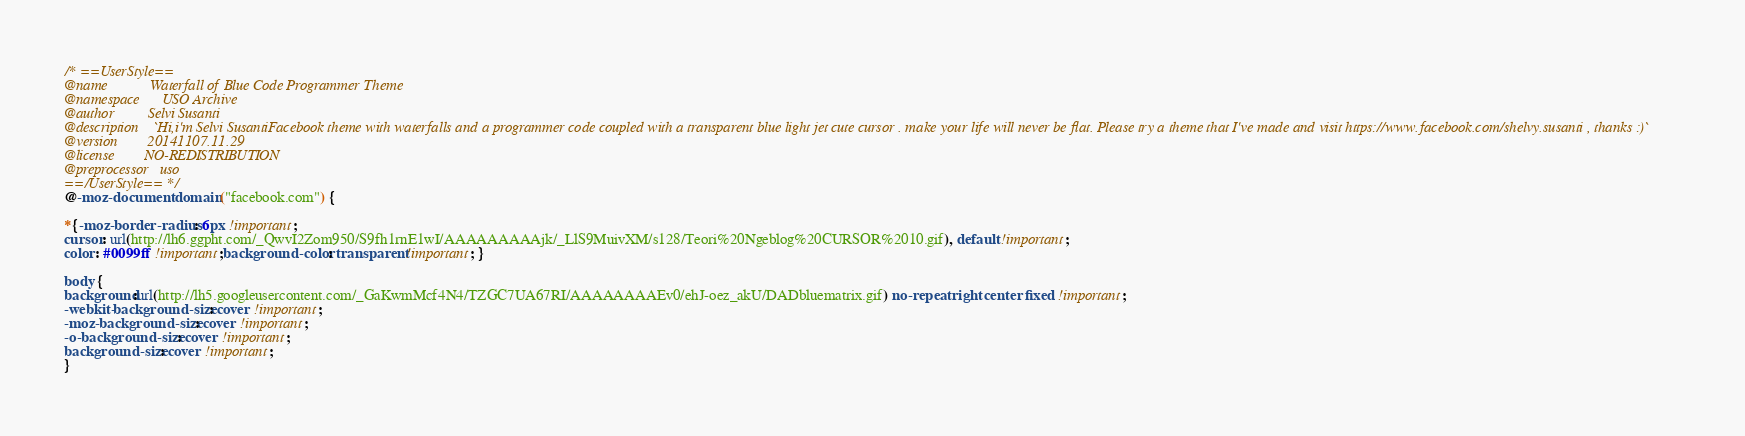Convert code to text. <code><loc_0><loc_0><loc_500><loc_500><_CSS_>/* ==UserStyle==
@name           Waterfall of Blue Code Programmer Theme
@namespace      USO Archive
@author         Selvi Susanti
@description    `Hi,i'm Selvi SusantiFacebook theme with waterfalls and a programmer code coupled with a transparent blue light jet cute cursor . make your life will never be flat. Please try a theme that I've made and visit https://www.facebook.com/shelvy.susanti , thanks :)`
@version        20141107.11.29
@license        NO-REDISTRIBUTION
@preprocessor   uso
==/UserStyle== */
@-moz-document domain("facebook.com") {

*{-moz-border-radius: 6px !important;
cursor: url(http://lh6.ggpht.com/_QwvI2Zom950/S9fh1rnE1wI/AAAAAAAAAjk/_LlS9MuivXM/s128/Teori%20Ngeblog%20CURSOR%2010.gif), default !important;
color: #0099ff !important;background-color: transparent !important; }

body {
background:url(http://lh5.googleusercontent.com/_GaKwmMcf4N4/TZGC7UA67RI/AAAAAAAAEv0/ehJ-oez_akU/DADbluematrix.gif) no-repeat right center fixed !important;
-webkit-background-size: cover !important;
-moz-background-size: cover !important;
-o-background-size: cover !important;
background-size: cover !important;
}
</code> 